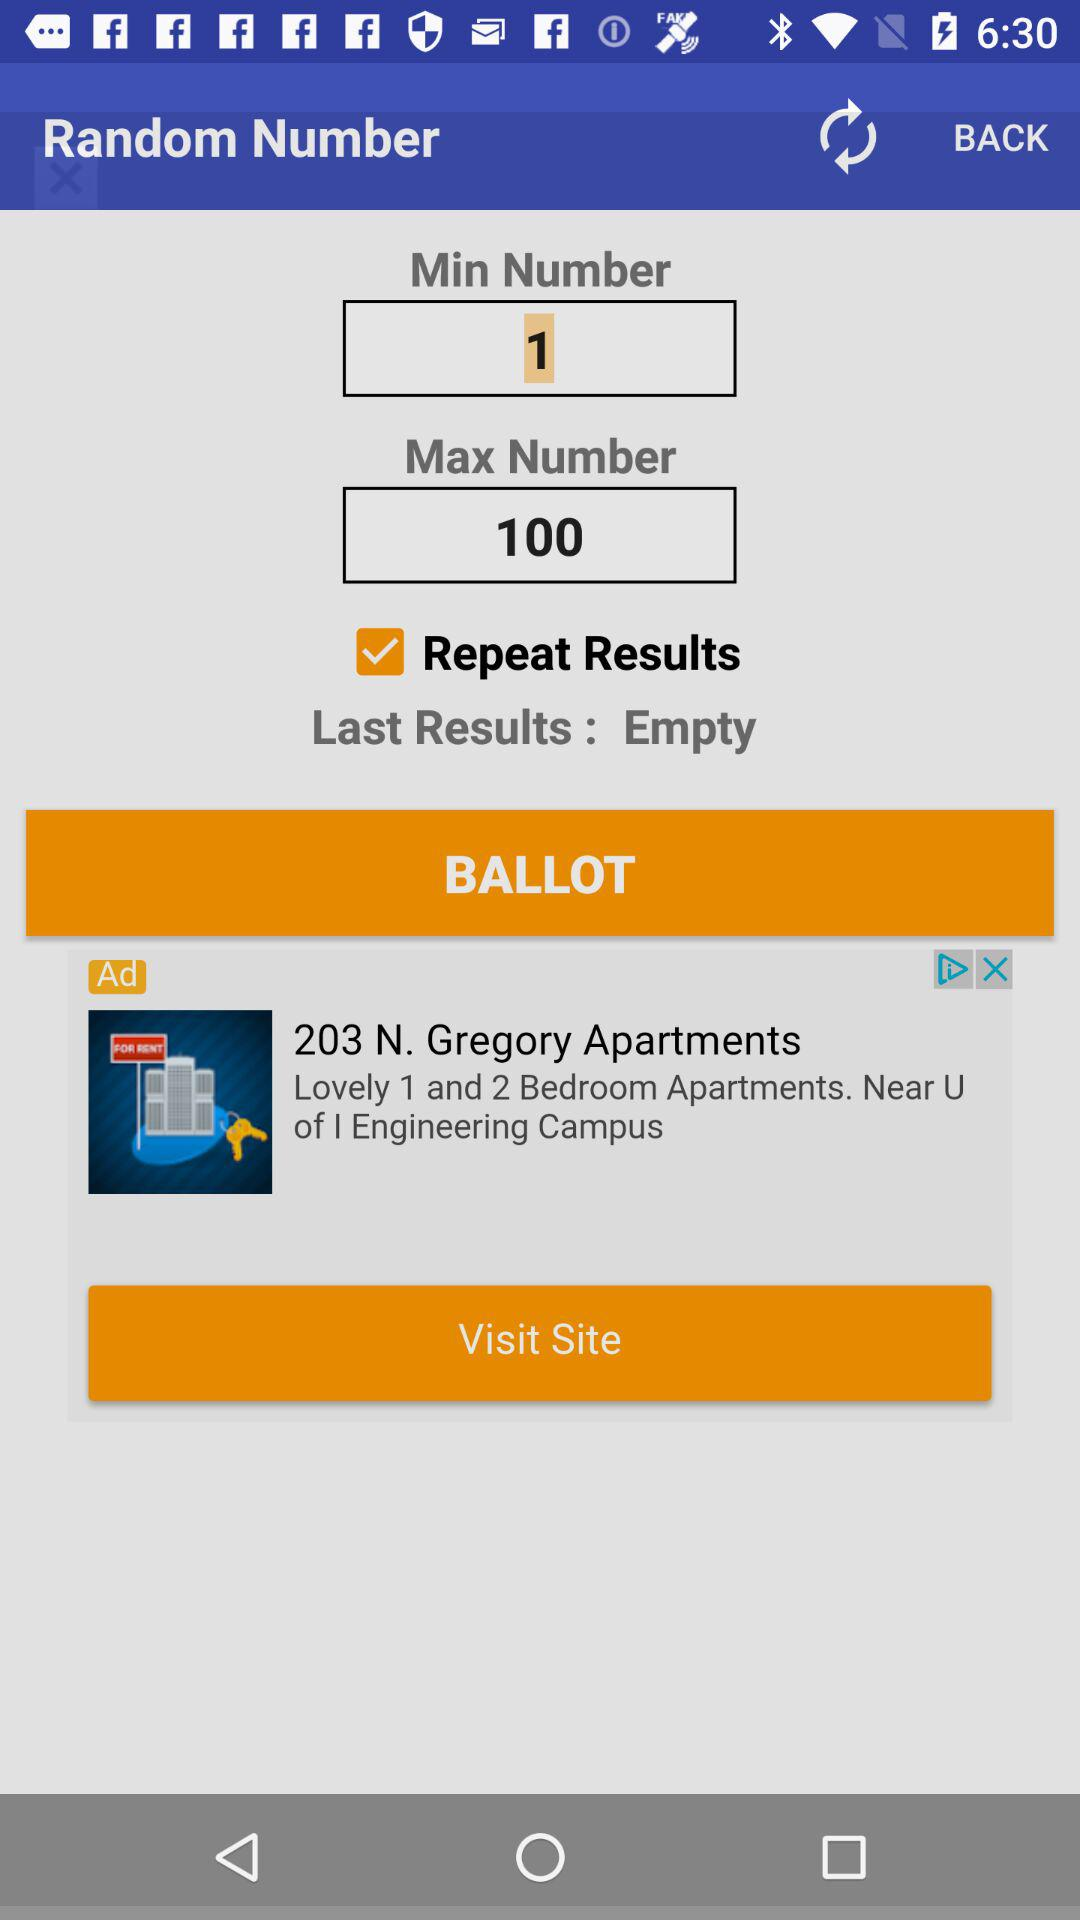What is the status of "Repeat Results"? The status is "on". 